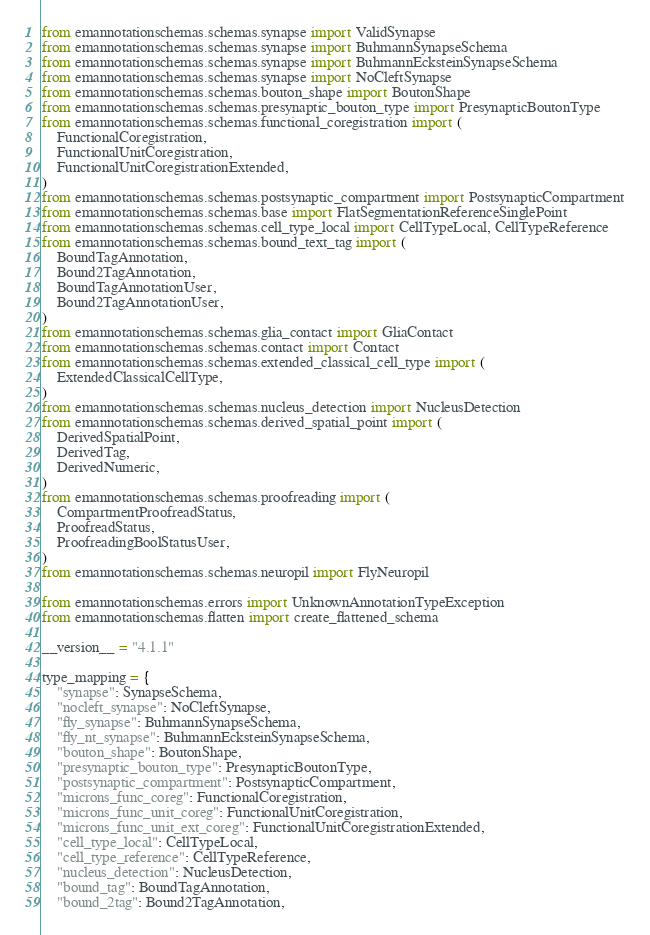<code> <loc_0><loc_0><loc_500><loc_500><_Python_>from emannotationschemas.schemas.synapse import ValidSynapse
from emannotationschemas.schemas.synapse import BuhmannSynapseSchema
from emannotationschemas.schemas.synapse import BuhmannEcksteinSynapseSchema
from emannotationschemas.schemas.synapse import NoCleftSynapse
from emannotationschemas.schemas.bouton_shape import BoutonShape
from emannotationschemas.schemas.presynaptic_bouton_type import PresynapticBoutonType
from emannotationschemas.schemas.functional_coregistration import (
    FunctionalCoregistration,
    FunctionalUnitCoregistration,
    FunctionalUnitCoregistrationExtended,
)
from emannotationschemas.schemas.postsynaptic_compartment import PostsynapticCompartment
from emannotationschemas.schemas.base import FlatSegmentationReferenceSinglePoint
from emannotationschemas.schemas.cell_type_local import CellTypeLocal, CellTypeReference
from emannotationschemas.schemas.bound_text_tag import (
    BoundTagAnnotation,
    Bound2TagAnnotation,
    BoundTagAnnotationUser,
    Bound2TagAnnotationUser,
)
from emannotationschemas.schemas.glia_contact import GliaContact
from emannotationschemas.schemas.contact import Contact
from emannotationschemas.schemas.extended_classical_cell_type import (
    ExtendedClassicalCellType,
)
from emannotationschemas.schemas.nucleus_detection import NucleusDetection
from emannotationschemas.schemas.derived_spatial_point import (
    DerivedSpatialPoint,
    DerivedTag,
    DerivedNumeric,
)
from emannotationschemas.schemas.proofreading import (
    CompartmentProofreadStatus,
    ProofreadStatus,
    ProofreadingBoolStatusUser,
)
from emannotationschemas.schemas.neuropil import FlyNeuropil

from emannotationschemas.errors import UnknownAnnotationTypeException
from emannotationschemas.flatten import create_flattened_schema

__version__ = "4.1.1"

type_mapping = {
    "synapse": SynapseSchema,
    "nocleft_synapse": NoCleftSynapse,
    "fly_synapse": BuhmannSynapseSchema,
    "fly_nt_synapse": BuhmannEcksteinSynapseSchema,
    "bouton_shape": BoutonShape,
    "presynaptic_bouton_type": PresynapticBoutonType,
    "postsynaptic_compartment": PostsynapticCompartment,
    "microns_func_coreg": FunctionalCoregistration,
    "microns_func_unit_coreg": FunctionalUnitCoregistration,
    "microns_func_unit_ext_coreg": FunctionalUnitCoregistrationExtended,
    "cell_type_local": CellTypeLocal,
    "cell_type_reference": CellTypeReference,
    "nucleus_detection": NucleusDetection,
    "bound_tag": BoundTagAnnotation,
    "bound_2tag": Bound2TagAnnotation,</code> 